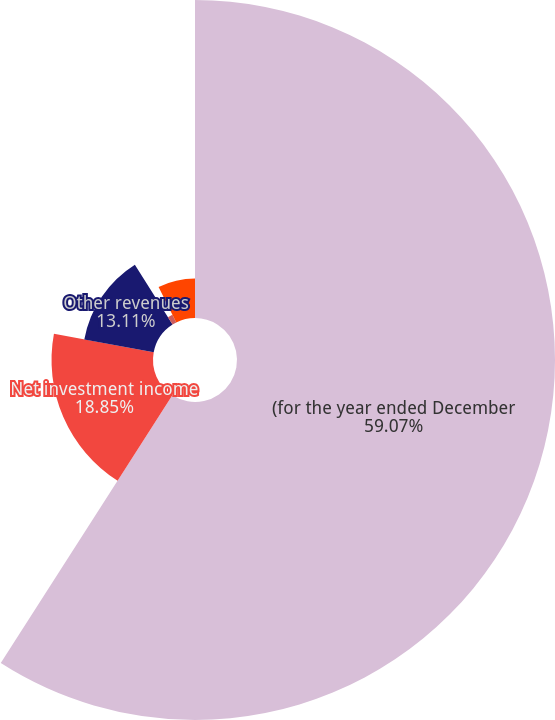Convert chart to OTSL. <chart><loc_0><loc_0><loc_500><loc_500><pie_chart><fcel>(for the year ended December<fcel>Net investment income<fcel>Other revenues<fcel>Loss and loss adjustment<fcel>GAAP combined ratio<nl><fcel>59.07%<fcel>18.85%<fcel>13.11%<fcel>1.61%<fcel>7.36%<nl></chart> 